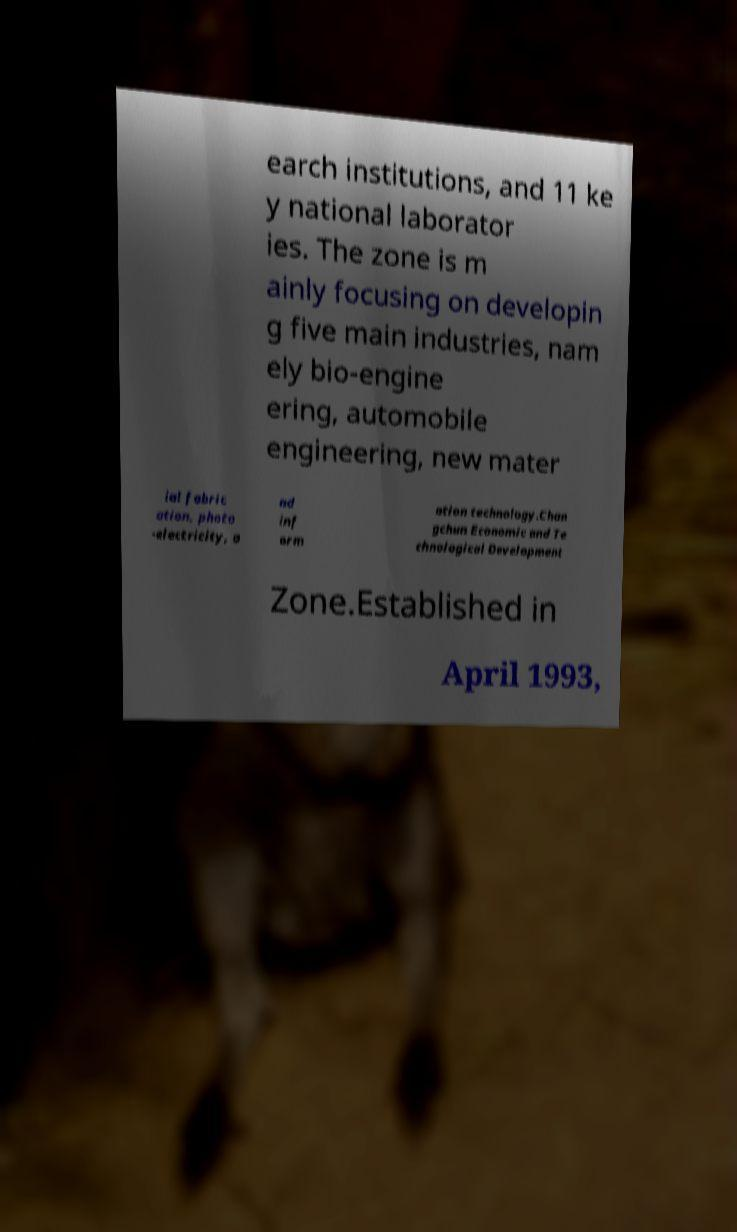Please read and relay the text visible in this image. What does it say? earch institutions, and 11 ke y national laborator ies. The zone is m ainly focusing on developin g five main industries, nam ely bio-engine ering, automobile engineering, new mater ial fabric ation, photo -electricity, a nd inf orm ation technology.Chan gchun Economic and Te chnological Development Zone.Established in April 1993, 